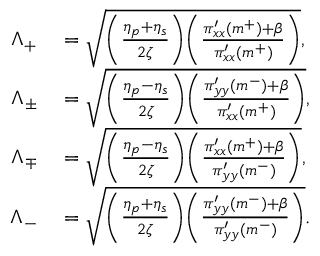Convert formula to latex. <formula><loc_0><loc_0><loc_500><loc_500>\begin{array} { r l } { \Lambda _ { + } } & = \sqrt { \left ( \frac { \eta _ { p } + \eta _ { s } } { 2 \zeta } \right ) \left ( \frac { \pi _ { x x } ^ { \prime } ( m ^ { + } ) + \beta } { \pi _ { x x } ^ { \prime } ( m ^ { + } ) } \right ) } , } \\ { \Lambda _ { \pm } } & = \sqrt { \left ( \frac { \eta _ { p } - \eta _ { s } } { 2 \zeta } \right ) \left ( \frac { \pi _ { y y } ^ { \prime } ( m ^ { - } ) + \beta } { \pi _ { x x } ^ { \prime } ( m ^ { + } ) } \right ) } , } \\ { \Lambda _ { \mp } } & = \sqrt { \left ( \frac { \eta _ { p } - \eta _ { s } } { 2 \zeta } \right ) \left ( \frac { \pi _ { x x } ^ { \prime } ( m ^ { + } ) + \beta } { \pi _ { y y } ^ { \prime } ( m ^ { - } ) } \right ) } , } \\ { \Lambda _ { - } } & = \sqrt { \left ( \frac { \eta _ { p } + \eta _ { s } } { 2 \zeta } \right ) \left ( \frac { \pi _ { y y } ^ { \prime } ( m ^ { - } ) + \beta } { \pi _ { y y } ^ { \prime } ( m ^ { - } ) } \right ) } . } \end{array}</formula> 